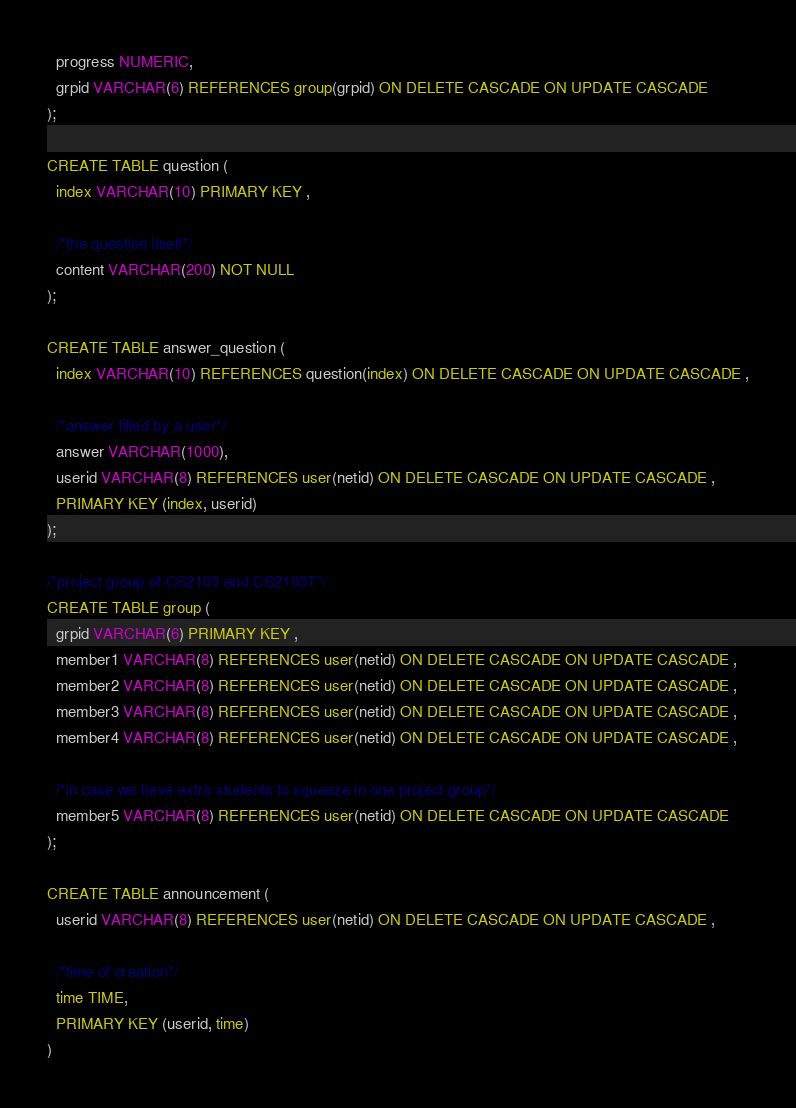<code> <loc_0><loc_0><loc_500><loc_500><_SQL_>  progress NUMERIC,
  grpid VARCHAR(6) REFERENCES group(grpid) ON DELETE CASCADE ON UPDATE CASCADE
);

CREATE TABLE question (
  index VARCHAR(10) PRIMARY KEY ,

  /*the question itself*/
  content VARCHAR(200) NOT NULL
);

CREATE TABLE answer_question (
  index VARCHAR(10) REFERENCES question(index) ON DELETE CASCADE ON UPDATE CASCADE ,

  /*answer filled by a user*/
  answer VARCHAR(1000),
  userid VARCHAR(8) REFERENCES user(netid) ON DELETE CASCADE ON UPDATE CASCADE ,
  PRIMARY KEY (index, userid)
);

/*project group of CS2103 and CS2103T*/
CREATE TABLE group (
  grpid VARCHAR(6) PRIMARY KEY ,
  member1 VARCHAR(8) REFERENCES user(netid) ON DELETE CASCADE ON UPDATE CASCADE ,
  member2 VARCHAR(8) REFERENCES user(netid) ON DELETE CASCADE ON UPDATE CASCADE ,
  member3 VARCHAR(8) REFERENCES user(netid) ON DELETE CASCADE ON UPDATE CASCADE ,
  member4 VARCHAR(8) REFERENCES user(netid) ON DELETE CASCADE ON UPDATE CASCADE ,

  /*in case we have extra students to squeeze in one project group*/
  member5 VARCHAR(8) REFERENCES user(netid) ON DELETE CASCADE ON UPDATE CASCADE
);

CREATE TABLE announcement (
  userid VARCHAR(8) REFERENCES user(netid) ON DELETE CASCADE ON UPDATE CASCADE ,

  /*time of creation*/
  time TIME,
  PRIMARY KEY (userid, time)
)
</code> 